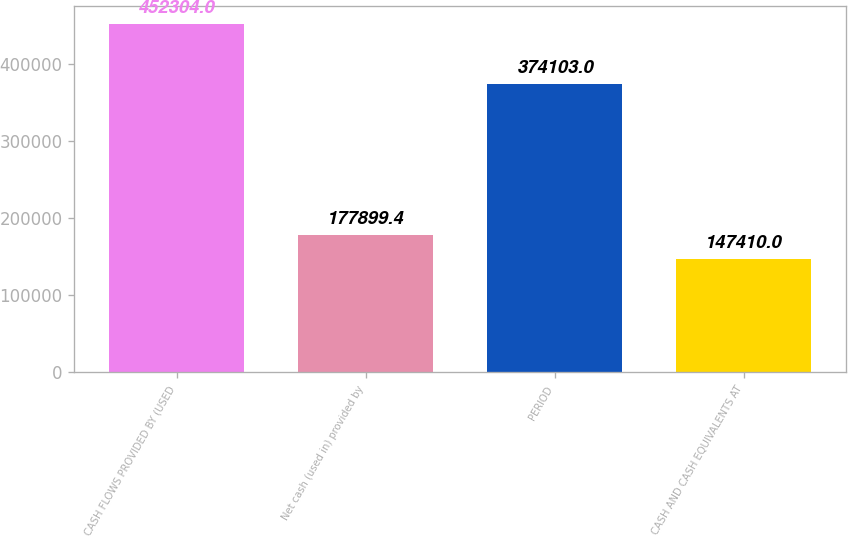Convert chart to OTSL. <chart><loc_0><loc_0><loc_500><loc_500><bar_chart><fcel>CASH FLOWS PROVIDED BY (USED<fcel>Net cash (used in) provided by<fcel>PERIOD<fcel>CASH AND CASH EQUIVALENTS AT<nl><fcel>452304<fcel>177899<fcel>374103<fcel>147410<nl></chart> 